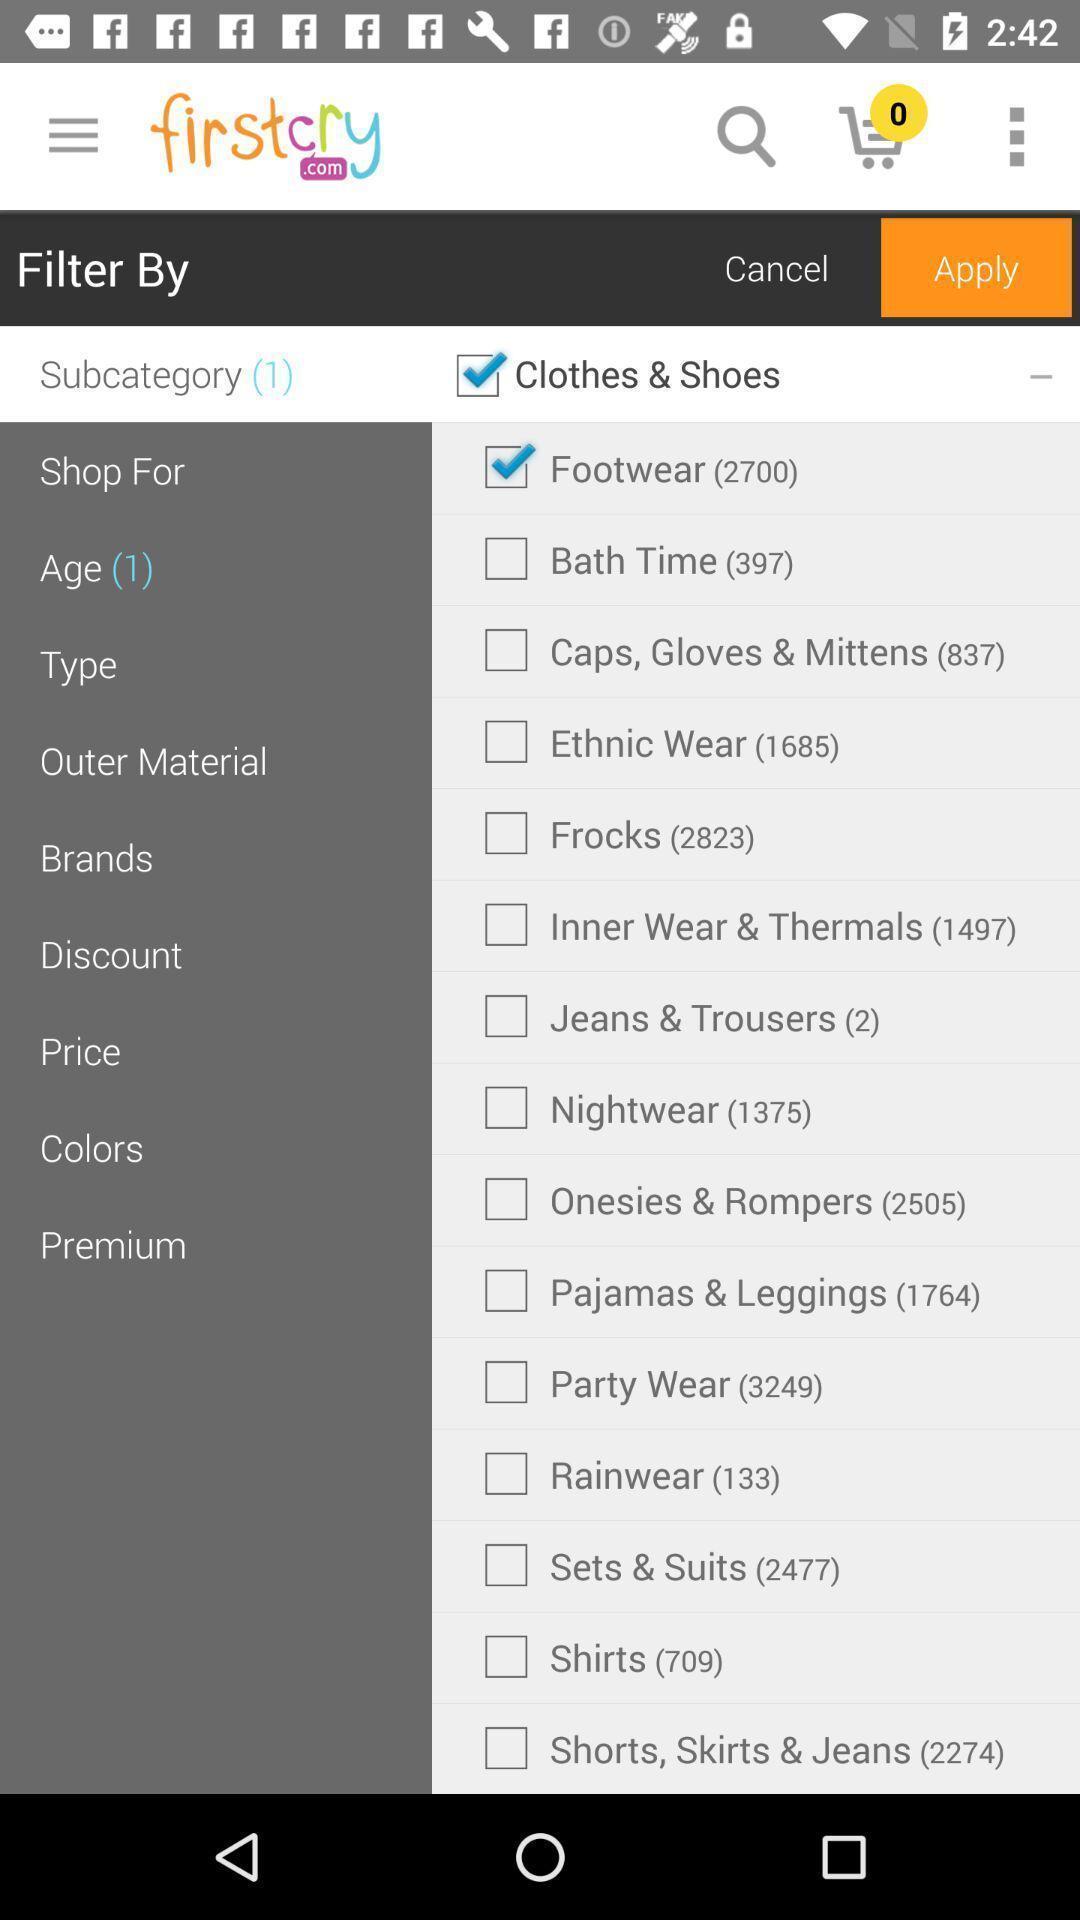Provide a detailed account of this screenshot. Screen displaying list of categories on a shopping app. 